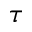<formula> <loc_0><loc_0><loc_500><loc_500>\tau</formula> 